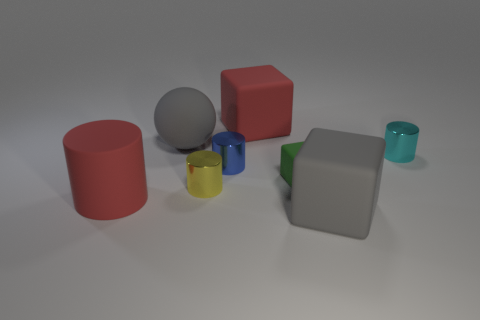Is the number of cyan cylinders greater than the number of small yellow metal balls?
Make the answer very short. Yes. Does the cyan metal thing have the same shape as the yellow thing?
Give a very brief answer. Yes. Does the big cube left of the tiny green object have the same color as the big cylinder that is in front of the tiny green cube?
Provide a succinct answer. Yes. Is the number of cylinders that are behind the tiny green matte object less than the number of things that are in front of the large gray sphere?
Keep it short and to the point. Yes. The large red object left of the large sphere has what shape?
Keep it short and to the point. Cylinder. There is a big thing that is the same color as the matte cylinder; what is its material?
Ensure brevity in your answer.  Rubber. How many other things are made of the same material as the large sphere?
Keep it short and to the point. 4. Do the tiny rubber object and the red rubber thing that is in front of the small yellow shiny object have the same shape?
Ensure brevity in your answer.  No. There is a small blue object that is the same material as the tiny yellow cylinder; what is its shape?
Your answer should be very brief. Cylinder. Are there more big red cylinders that are right of the ball than tiny blue shiny cylinders that are behind the cyan cylinder?
Offer a very short reply. No. 